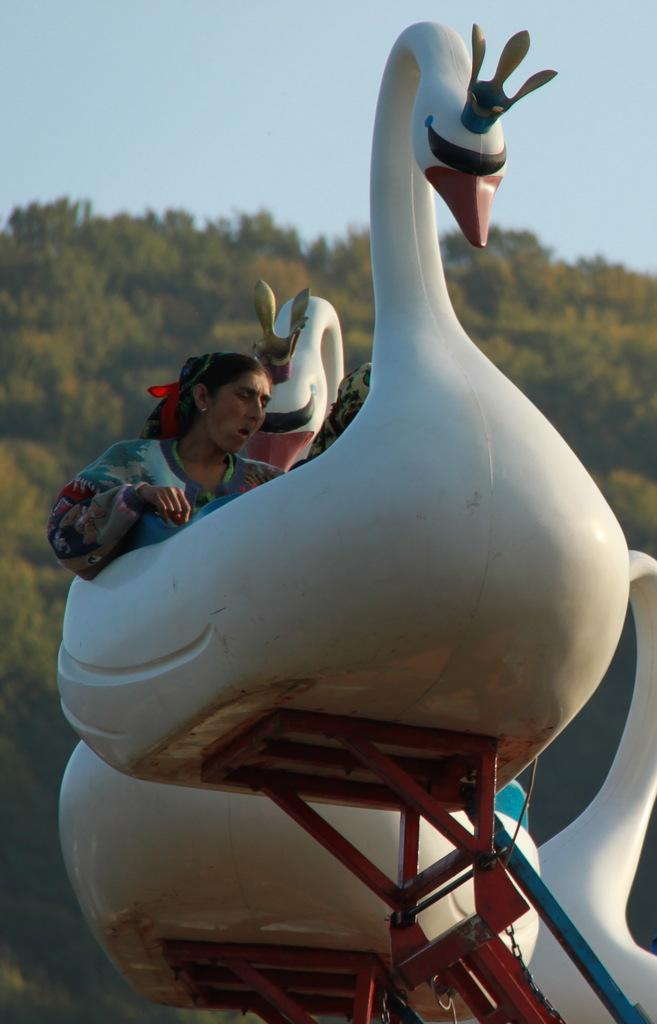What is the main subject of the image? There is a carnival swan in the image. Who is interacting with the swan? A woman is sitting on the swan. What can be seen in the background of the image? There are many trees in the background of the image. What is visible at the top of the image? The sky is visible at the top of the image. Can you tell me how many fish are swimming in the sky in the image? There are no fish visible in the sky in the image. 